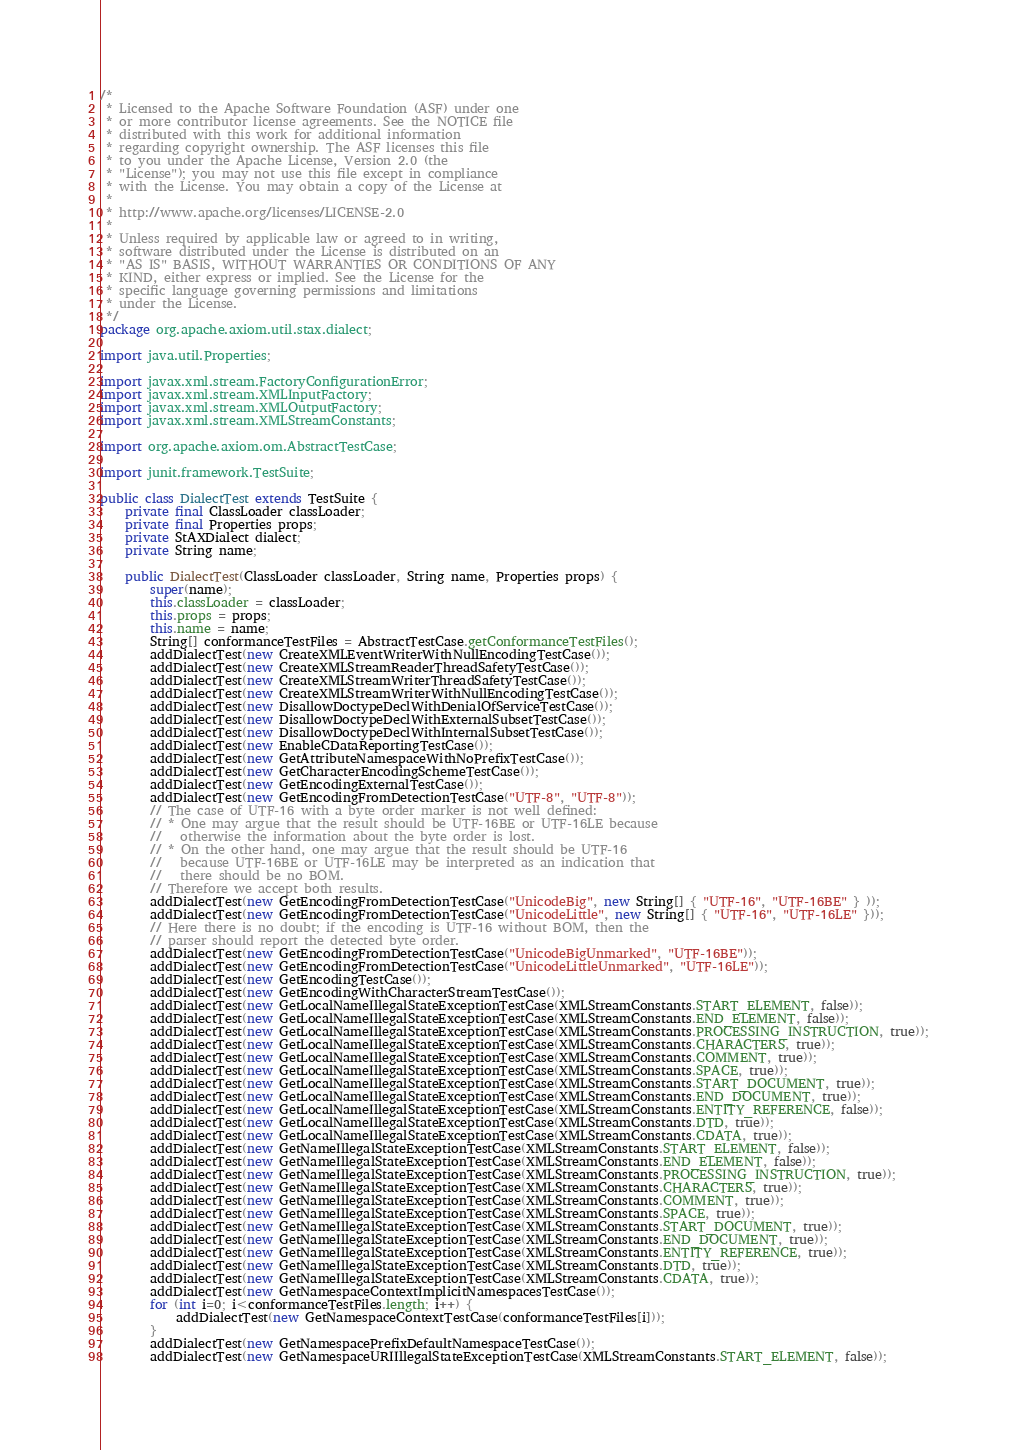<code> <loc_0><loc_0><loc_500><loc_500><_Java_>/*
 * Licensed to the Apache Software Foundation (ASF) under one
 * or more contributor license agreements. See the NOTICE file
 * distributed with this work for additional information
 * regarding copyright ownership. The ASF licenses this file
 * to you under the Apache License, Version 2.0 (the
 * "License"); you may not use this file except in compliance
 * with the License. You may obtain a copy of the License at
 *
 * http://www.apache.org/licenses/LICENSE-2.0
 *
 * Unless required by applicable law or agreed to in writing,
 * software distributed under the License is distributed on an
 * "AS IS" BASIS, WITHOUT WARRANTIES OR CONDITIONS OF ANY
 * KIND, either express or implied. See the License for the
 * specific language governing permissions and limitations
 * under the License.
 */
package org.apache.axiom.util.stax.dialect;

import java.util.Properties;

import javax.xml.stream.FactoryConfigurationError;
import javax.xml.stream.XMLInputFactory;
import javax.xml.stream.XMLOutputFactory;
import javax.xml.stream.XMLStreamConstants;

import org.apache.axiom.om.AbstractTestCase;

import junit.framework.TestSuite;

public class DialectTest extends TestSuite {
    private final ClassLoader classLoader;
    private final Properties props;
    private StAXDialect dialect;
    private String name;
    
    public DialectTest(ClassLoader classLoader, String name, Properties props) {
        super(name);
        this.classLoader = classLoader;
        this.props = props;
        this.name = name;
        String[] conformanceTestFiles = AbstractTestCase.getConformanceTestFiles();
        addDialectTest(new CreateXMLEventWriterWithNullEncodingTestCase());
        addDialectTest(new CreateXMLStreamReaderThreadSafetyTestCase());
        addDialectTest(new CreateXMLStreamWriterThreadSafetyTestCase());
        addDialectTest(new CreateXMLStreamWriterWithNullEncodingTestCase());
        addDialectTest(new DisallowDoctypeDeclWithDenialOfServiceTestCase());
        addDialectTest(new DisallowDoctypeDeclWithExternalSubsetTestCase());
        addDialectTest(new DisallowDoctypeDeclWithInternalSubsetTestCase());
        addDialectTest(new EnableCDataReportingTestCase());
        addDialectTest(new GetAttributeNamespaceWithNoPrefixTestCase());
        addDialectTest(new GetCharacterEncodingSchemeTestCase());
        addDialectTest(new GetEncodingExternalTestCase());
        addDialectTest(new GetEncodingFromDetectionTestCase("UTF-8", "UTF-8"));
        // The case of UTF-16 with a byte order marker is not well defined:
        // * One may argue that the result should be UTF-16BE or UTF-16LE because
        //   otherwise the information about the byte order is lost.
        // * On the other hand, one may argue that the result should be UTF-16
        //   because UTF-16BE or UTF-16LE may be interpreted as an indication that
        //   there should be no BOM.
        // Therefore we accept both results.
        addDialectTest(new GetEncodingFromDetectionTestCase("UnicodeBig", new String[] { "UTF-16", "UTF-16BE" } ));
        addDialectTest(new GetEncodingFromDetectionTestCase("UnicodeLittle", new String[] { "UTF-16", "UTF-16LE" }));
        // Here there is no doubt; if the encoding is UTF-16 without BOM, then the
        // parser should report the detected byte order.
        addDialectTest(new GetEncodingFromDetectionTestCase("UnicodeBigUnmarked", "UTF-16BE"));
        addDialectTest(new GetEncodingFromDetectionTestCase("UnicodeLittleUnmarked", "UTF-16LE"));
        addDialectTest(new GetEncodingTestCase());
        addDialectTest(new GetEncodingWithCharacterStreamTestCase());
        addDialectTest(new GetLocalNameIllegalStateExceptionTestCase(XMLStreamConstants.START_ELEMENT, false));
        addDialectTest(new GetLocalNameIllegalStateExceptionTestCase(XMLStreamConstants.END_ELEMENT, false));
        addDialectTest(new GetLocalNameIllegalStateExceptionTestCase(XMLStreamConstants.PROCESSING_INSTRUCTION, true));
        addDialectTest(new GetLocalNameIllegalStateExceptionTestCase(XMLStreamConstants.CHARACTERS, true));
        addDialectTest(new GetLocalNameIllegalStateExceptionTestCase(XMLStreamConstants.COMMENT, true));
        addDialectTest(new GetLocalNameIllegalStateExceptionTestCase(XMLStreamConstants.SPACE, true));
        addDialectTest(new GetLocalNameIllegalStateExceptionTestCase(XMLStreamConstants.START_DOCUMENT, true));
        addDialectTest(new GetLocalNameIllegalStateExceptionTestCase(XMLStreamConstants.END_DOCUMENT, true));
        addDialectTest(new GetLocalNameIllegalStateExceptionTestCase(XMLStreamConstants.ENTITY_REFERENCE, false));
        addDialectTest(new GetLocalNameIllegalStateExceptionTestCase(XMLStreamConstants.DTD, true));
        addDialectTest(new GetLocalNameIllegalStateExceptionTestCase(XMLStreamConstants.CDATA, true));
        addDialectTest(new GetNameIllegalStateExceptionTestCase(XMLStreamConstants.START_ELEMENT, false));
        addDialectTest(new GetNameIllegalStateExceptionTestCase(XMLStreamConstants.END_ELEMENT, false));
        addDialectTest(new GetNameIllegalStateExceptionTestCase(XMLStreamConstants.PROCESSING_INSTRUCTION, true));
        addDialectTest(new GetNameIllegalStateExceptionTestCase(XMLStreamConstants.CHARACTERS, true));
        addDialectTest(new GetNameIllegalStateExceptionTestCase(XMLStreamConstants.COMMENT, true));
        addDialectTest(new GetNameIllegalStateExceptionTestCase(XMLStreamConstants.SPACE, true));
        addDialectTest(new GetNameIllegalStateExceptionTestCase(XMLStreamConstants.START_DOCUMENT, true));
        addDialectTest(new GetNameIllegalStateExceptionTestCase(XMLStreamConstants.END_DOCUMENT, true));
        addDialectTest(new GetNameIllegalStateExceptionTestCase(XMLStreamConstants.ENTITY_REFERENCE, true));
        addDialectTest(new GetNameIllegalStateExceptionTestCase(XMLStreamConstants.DTD, true));
        addDialectTest(new GetNameIllegalStateExceptionTestCase(XMLStreamConstants.CDATA, true));
        addDialectTest(new GetNamespaceContextImplicitNamespacesTestCase());
        for (int i=0; i<conformanceTestFiles.length; i++) {
            addDialectTest(new GetNamespaceContextTestCase(conformanceTestFiles[i]));
        }
        addDialectTest(new GetNamespacePrefixDefaultNamespaceTestCase());
        addDialectTest(new GetNamespaceURIIllegalStateExceptionTestCase(XMLStreamConstants.START_ELEMENT, false));</code> 